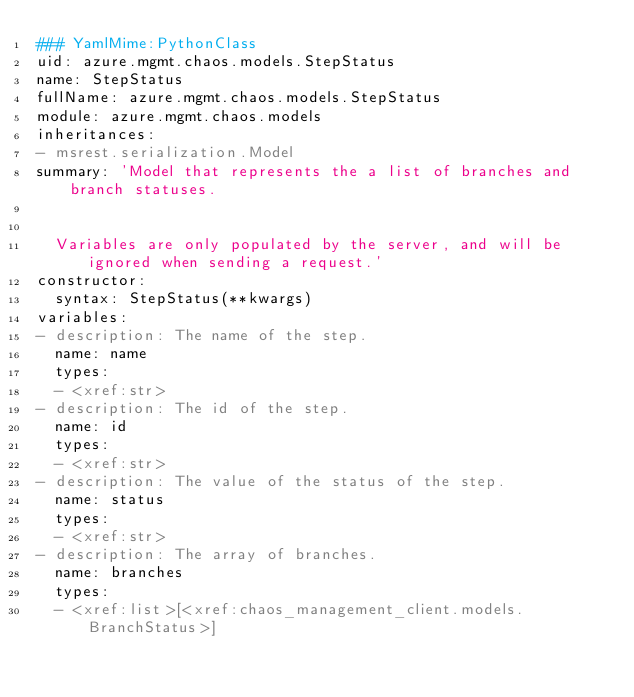Convert code to text. <code><loc_0><loc_0><loc_500><loc_500><_YAML_>### YamlMime:PythonClass
uid: azure.mgmt.chaos.models.StepStatus
name: StepStatus
fullName: azure.mgmt.chaos.models.StepStatus
module: azure.mgmt.chaos.models
inheritances:
- msrest.serialization.Model
summary: 'Model that represents the a list of branches and branch statuses.


  Variables are only populated by the server, and will be ignored when sending a request.'
constructor:
  syntax: StepStatus(**kwargs)
variables:
- description: The name of the step.
  name: name
  types:
  - <xref:str>
- description: The id of the step.
  name: id
  types:
  - <xref:str>
- description: The value of the status of the step.
  name: status
  types:
  - <xref:str>
- description: The array of branches.
  name: branches
  types:
  - <xref:list>[<xref:chaos_management_client.models.BranchStatus>]
</code> 